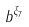Convert formula to latex. <formula><loc_0><loc_0><loc_500><loc_500>b ^ { \xi _ { 7 } }</formula> 